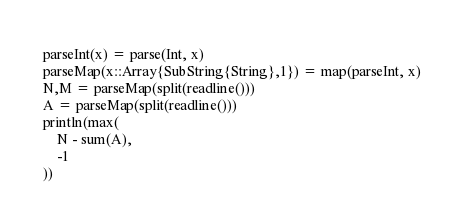<code> <loc_0><loc_0><loc_500><loc_500><_Julia_>parseInt(x) = parse(Int, x)
parseMap(x::Array{SubString{String},1}) = map(parseInt, x)
N,M = parseMap(split(readline()))
A = parseMap(split(readline()))
println(max(
    N - sum(A),
    -1
))
</code> 